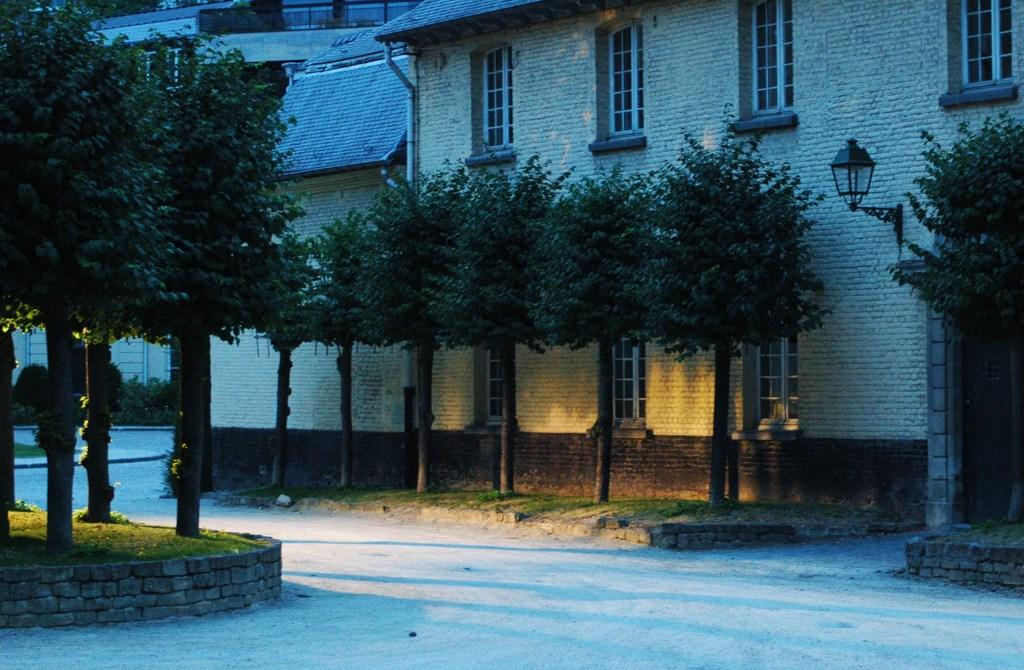What type of structures can be seen in the image? There are buildings in the image. What natural elements are present in the image? There are trees and grass in the image. Can you describe any man-made objects on the wall? There is a light and a pipe on the wall. What type of surface is at the bottom of the image? There is a pavement at the bottom of the image. What type of board is the writer using to create the image? There is no board or writer present in the image; it is a photograph of a scene. What type of vegetable is growing in the image? There is no vegetable, such as celery, present in the image. 